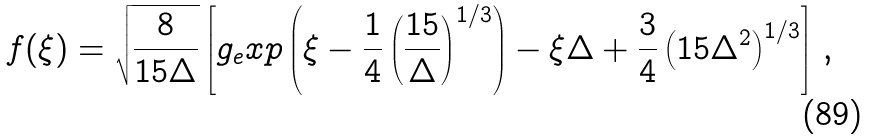<formula> <loc_0><loc_0><loc_500><loc_500>f ( \xi ) = \sqrt { \frac { 8 } { 1 5 \Delta } } \left [ g _ { e } x p \left ( \xi - \frac { 1 } { 4 } \left ( \frac { 1 5 } { \Delta } \right ) ^ { 1 / 3 } \right ) - \xi \Delta + \frac { 3 } { 4 } \left ( 1 5 \Delta ^ { 2 } \right ) ^ { 1 / 3 } \right ] \, ,</formula> 